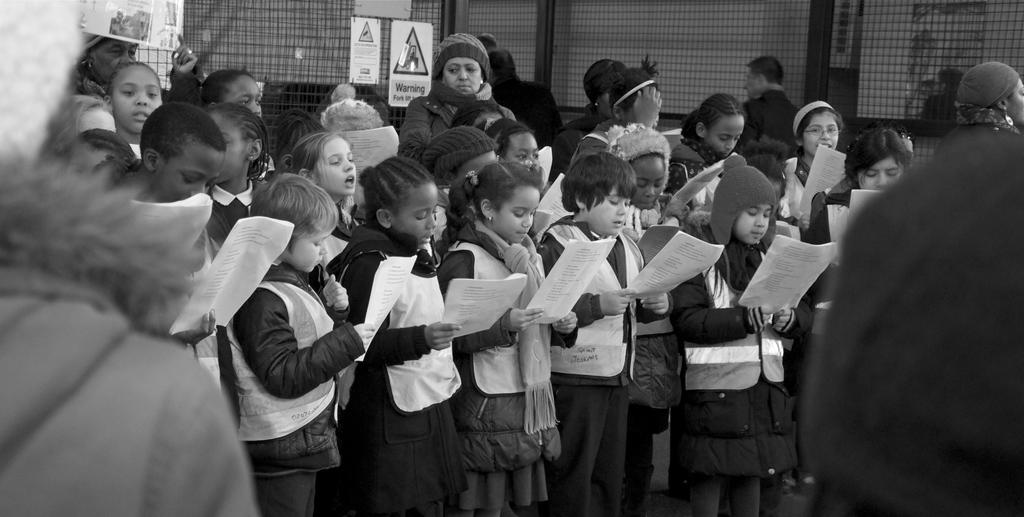What are the people in the image doing? The people in the image are standing and holding papers. What can be seen on the fencing in the image? Banners and sign boards are present on the fencing in the image. What is behind the fencing in the image? There is a wall behind the fencing in the image. What type of skirt is the writer wearing in the image? There is no writer or skirt present in the image. Can you describe the bite marks on the papers held by the people in the image? There are no bite marks on the papers held by the people in the image. 